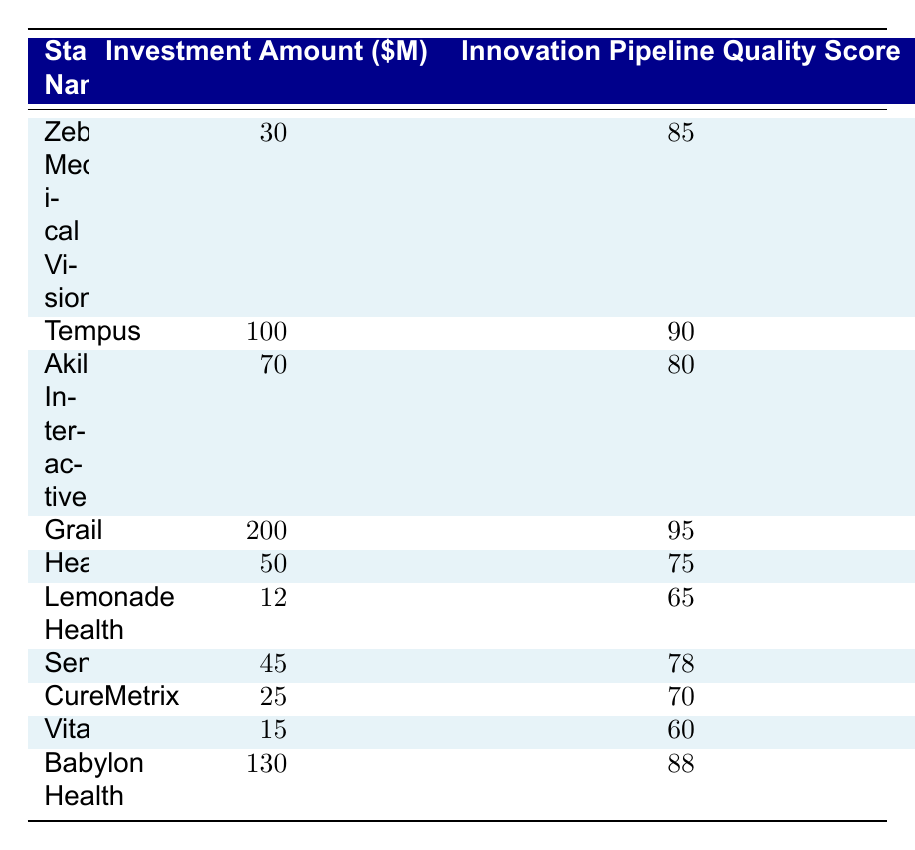What is the highest investment amount among the health tech startups? The table shows various investment amounts. Scanning the "Investment Amount" column, the highest value is 200 million for Grail.
Answer: 200 million What is the innovation pipeline quality score of Lemonade Health? By locating Lemonade Health in the "Startup Name" column, we find its corresponding score in the "Innovation Pipeline Quality Score" column, which is 65.
Answer: 65 Which startup has an innovation pipeline quality score of 90? When looking through the "Innovation Pipeline Quality Score" column, Tempus is the startup that has the score of 90.
Answer: Tempus What is the average investment amount for all the startups listed? To calculate the average, we first sum all investment amounts: (30 + 100 + 70 + 200 + 50 + 12 + 45 + 25 + 15 + 130) = 682 million. Dividing this by the number of startups (10), we get 68.2 million.
Answer: 68.2 million Is there a startup with an investment amount less than 20 million? By reviewing the "Investment Amount" column, the lowest investment listed is 12 million for Lemonade Health, which confirms that there is indeed a startup under 20 million.
Answer: Yes What is the difference in the innovation pipeline quality score between the highest and lowest scoring startups? The highest score is 95 for Grail and the lowest score is 60 for Vitagene. Calculating the difference: 95 - 60 = 35.
Answer: 35 How many startups have an innovation pipeline quality score of 80 or above? We can identify the following startups with scores of 80 or more: Zebra Medical Vision (85), Tempus (90), Grail (95), Akili Interactive (80), and Babylon Health (88). This totals to 5 startups.
Answer: 5 Does the startup with the highest investment amount have the highest innovation pipeline quality score? Grail has the highest investment amount of 200 million and also holds the highest innovation pipeline quality score of 95. Thus, it is true that the startup with the highest investment amount also has the highest score.
Answer: Yes What is the median innovation pipeline quality score of the startups? First, we list the scores in order: 60, 65, 70, 75, 78, 80, 85, 88, 90, 95. Since there are 10 scores, the median will be the average of the 5th (78) and 6th (80) scores: (78 + 80) / 2 = 79.
Answer: 79 